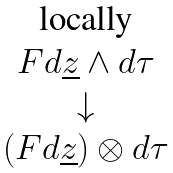Convert formula to latex. <formula><loc_0><loc_0><loc_500><loc_500>\begin{matrix} \text {locally} \\ F d \underline { z } \wedge d \tau \\ \downarrow \\ ( F d \underline { z } ) \otimes d \tau \end{matrix}</formula> 